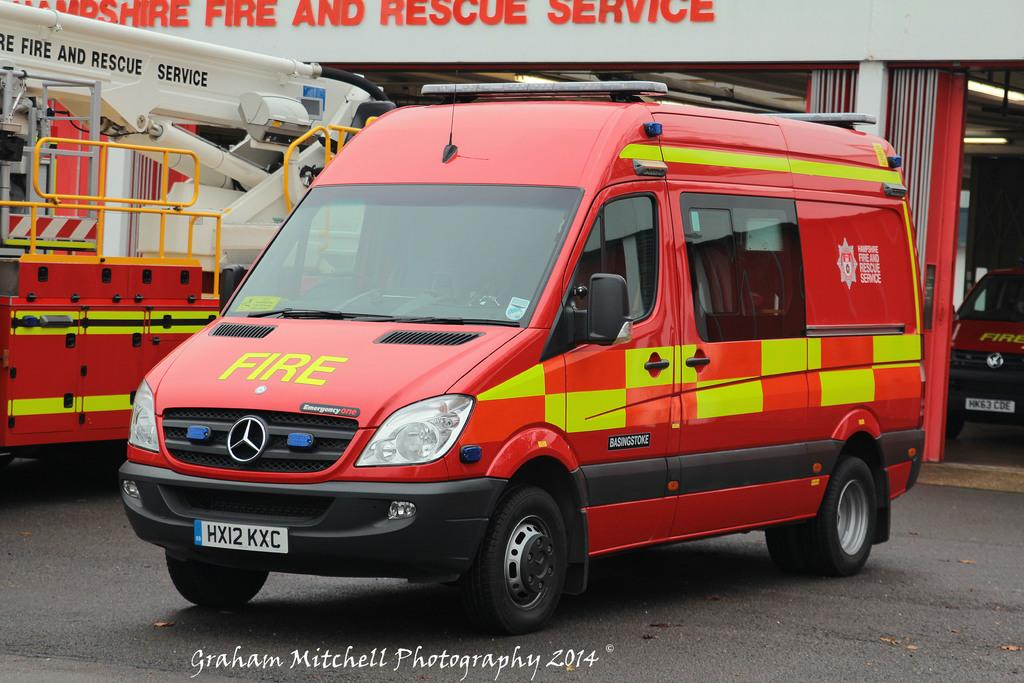<image>
Describe the image concisely. A red Mercedes Fire vehicle at a fire station. 